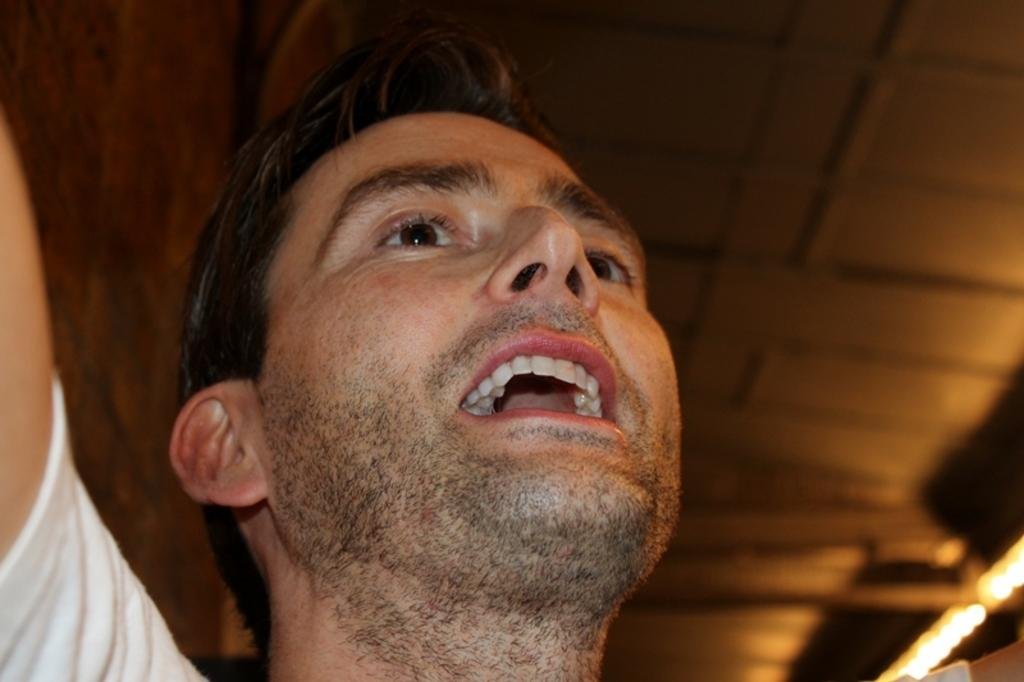Who is present in the image? There is a man in the image. What is the man wearing? The man is wearing a white t-shirt. What can be seen on the left side of the image? There is a wall on the left side of the image. What is the color of the wall? The wall is in brown color. What is visible in the background of the image? There is a ceiling visible in the background of the image. Where is the nearest park or zoo in the image? The image does not show any parks or zoos, so it is not possible to determine their locations from the image. 